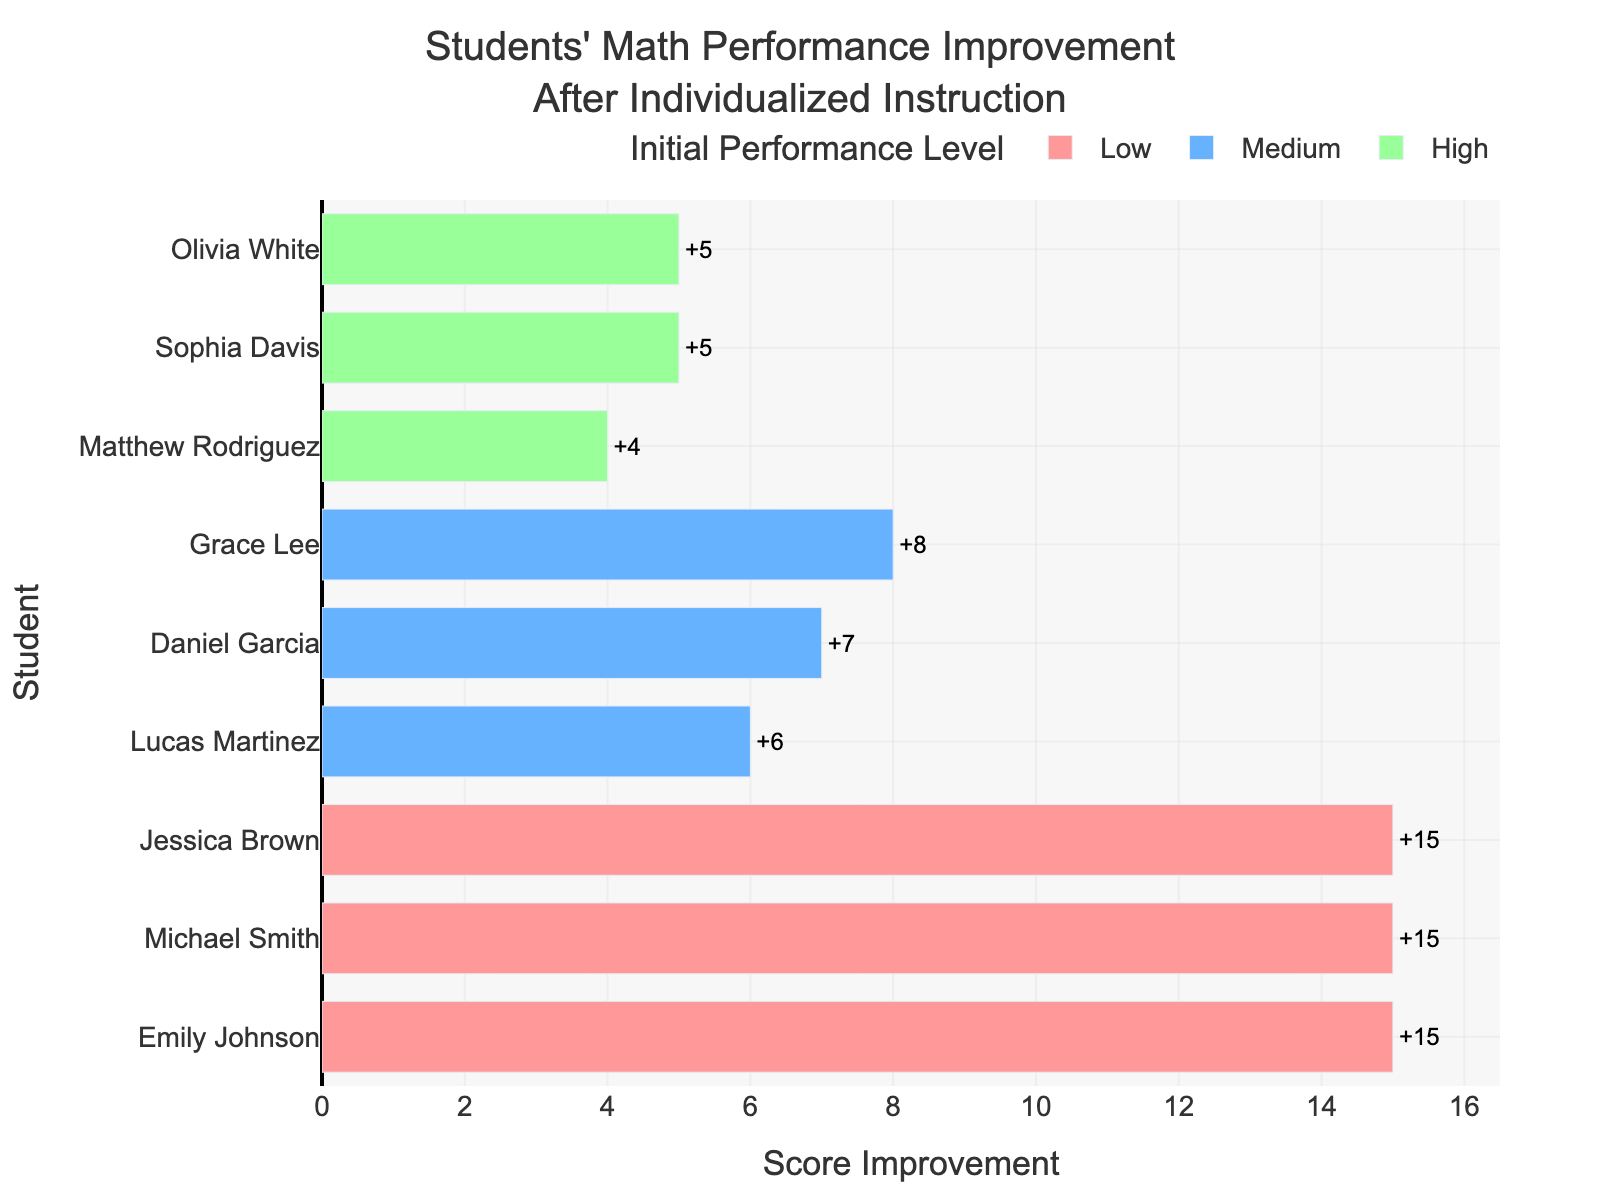How much did Emily Johnson's score improve after individualized instruction? Emily Johnson's improvement can be found by looking at the bar representing her and reading the score difference value displayed.
Answer: 15 Which student in the "High" performance level had the least improvement? Compare the lengths and positions of the bars for students under the "High" performance level category. The shortest bar corresponds to Sophia Davis.
Answer: Sophia Davis What's the average improvement score for students in the "Medium" performance level? Sum the improvement scores for Daniel Garcia (7), Lucas Martinez (6), and Grace Lee (8), then divide by the number of students (3). Calculation is (7 + 6 + 8) / 3.
Answer: 7 Who had the highest overall improvement, and what was their improvement score? Identify the longest bar across all segments and read the value. This bar belongs to Grace Lee.
Answer: Grace Lee with a score of 8 Compare the maximum improvement in the "Low" and "High" performance levels. Which is higher and by how much? Identify the maximum improvement in "Low" (15 by Emily Johnson) and in "High" (5 by Matthew Rodriguez) and compare them. Compute the difference (15 - 5).
Answer: "Low" is higher by 10 What is the total improvement score of students in the "Low" performance level? Sum the improvement scores of Emily Johnson (15), Michael Smith (15), and Jessica Brown (15).
Answer: 45 Which performance level had the most consistent improvement scores? Evaluate the range of improvement scores within each performance level. "Low" level has consistent scores of 15 for all its students, which is the same across the board.
Answer: Low How many students improved by more than 5 points? Count the number of bars where the improvement score is greater than 5: Emily Johnson, Michael Smith, Jessica Brown, Daniel Garcia, Grace Lee, Olivia White.
Answer: 6 What's the combined improvement score for students with initially "High" performance levels? Sum the improvement scores of Sophia Davis (5), Matthew Rodriguez (4), and Olivia White (5).
Answer: 14 